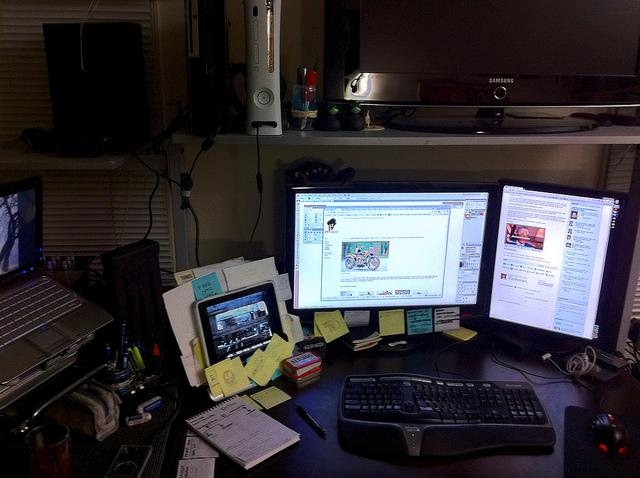What is the item called that has the red lights emanating from it? Please explain your reasoning. mouse. You can see the mouse is lit up. it's used to control the computer. 